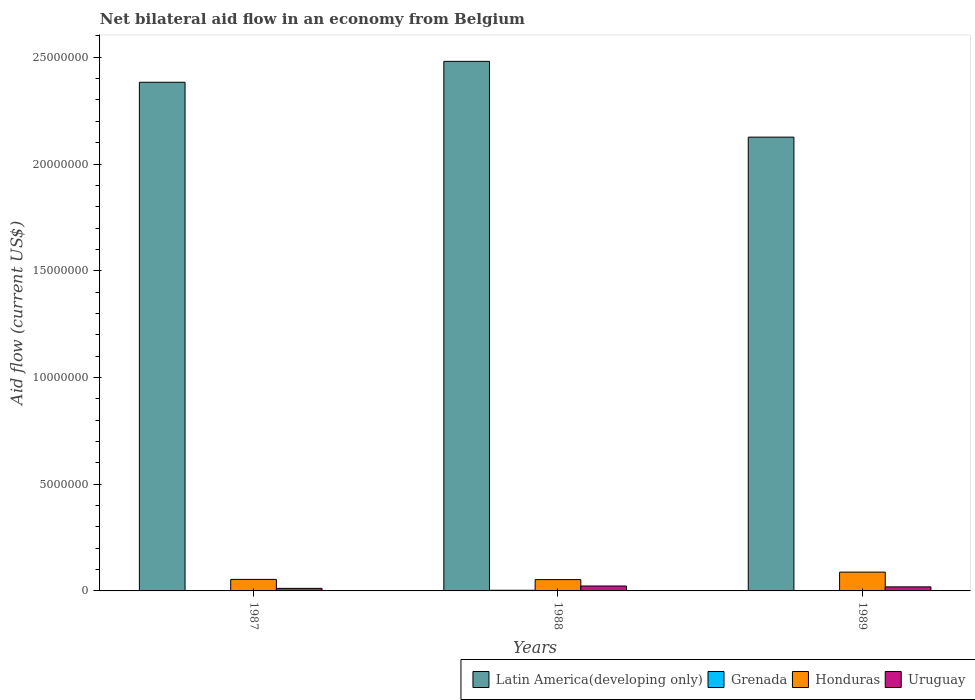How many different coloured bars are there?
Your response must be concise. 4. Are the number of bars per tick equal to the number of legend labels?
Offer a very short reply. Yes. Are the number of bars on each tick of the X-axis equal?
Offer a terse response. Yes. How many bars are there on the 1st tick from the right?
Your answer should be compact. 4. What is the net bilateral aid flow in Latin America(developing only) in 1988?
Your answer should be compact. 2.48e+07. Across all years, what is the minimum net bilateral aid flow in Latin America(developing only)?
Your response must be concise. 2.13e+07. What is the total net bilateral aid flow in Uruguay in the graph?
Provide a succinct answer. 5.40e+05. What is the difference between the net bilateral aid flow in Grenada in 1987 and that in 1989?
Keep it short and to the point. 0. What is the difference between the net bilateral aid flow in Uruguay in 1988 and the net bilateral aid flow in Honduras in 1989?
Your answer should be compact. -6.50e+05. What is the average net bilateral aid flow in Grenada per year?
Provide a succinct answer. 1.67e+04. In how many years, is the net bilateral aid flow in Honduras greater than 7000000 US$?
Your answer should be very brief. 0. What is the ratio of the net bilateral aid flow in Latin America(developing only) in 1987 to that in 1989?
Your response must be concise. 1.12. Is the net bilateral aid flow in Grenada in 1988 less than that in 1989?
Your answer should be compact. No. What is the difference between the highest and the second highest net bilateral aid flow in Grenada?
Your answer should be very brief. 2.00e+04. What is the difference between the highest and the lowest net bilateral aid flow in Honduras?
Make the answer very short. 3.50e+05. What does the 3rd bar from the left in 1988 represents?
Keep it short and to the point. Honduras. What does the 2nd bar from the right in 1987 represents?
Give a very brief answer. Honduras. Is it the case that in every year, the sum of the net bilateral aid flow in Grenada and net bilateral aid flow in Honduras is greater than the net bilateral aid flow in Latin America(developing only)?
Give a very brief answer. No. Are all the bars in the graph horizontal?
Keep it short and to the point. No. What is the difference between two consecutive major ticks on the Y-axis?
Provide a succinct answer. 5.00e+06. Are the values on the major ticks of Y-axis written in scientific E-notation?
Provide a succinct answer. No. Does the graph contain any zero values?
Make the answer very short. No. Where does the legend appear in the graph?
Give a very brief answer. Bottom right. How many legend labels are there?
Keep it short and to the point. 4. How are the legend labels stacked?
Your answer should be very brief. Horizontal. What is the title of the graph?
Provide a succinct answer. Net bilateral aid flow in an economy from Belgium. Does "Libya" appear as one of the legend labels in the graph?
Provide a short and direct response. No. What is the Aid flow (current US$) of Latin America(developing only) in 1987?
Offer a very short reply. 2.38e+07. What is the Aid flow (current US$) of Honduras in 1987?
Make the answer very short. 5.40e+05. What is the Aid flow (current US$) in Uruguay in 1987?
Your response must be concise. 1.20e+05. What is the Aid flow (current US$) in Latin America(developing only) in 1988?
Offer a very short reply. 2.48e+07. What is the Aid flow (current US$) of Grenada in 1988?
Offer a terse response. 3.00e+04. What is the Aid flow (current US$) of Honduras in 1988?
Ensure brevity in your answer.  5.30e+05. What is the Aid flow (current US$) of Uruguay in 1988?
Offer a terse response. 2.30e+05. What is the Aid flow (current US$) of Latin America(developing only) in 1989?
Offer a terse response. 2.13e+07. What is the Aid flow (current US$) of Honduras in 1989?
Provide a short and direct response. 8.80e+05. Across all years, what is the maximum Aid flow (current US$) of Latin America(developing only)?
Keep it short and to the point. 2.48e+07. Across all years, what is the maximum Aid flow (current US$) of Honduras?
Offer a terse response. 8.80e+05. Across all years, what is the maximum Aid flow (current US$) in Uruguay?
Your response must be concise. 2.30e+05. Across all years, what is the minimum Aid flow (current US$) in Latin America(developing only)?
Give a very brief answer. 2.13e+07. Across all years, what is the minimum Aid flow (current US$) in Grenada?
Provide a succinct answer. 10000. Across all years, what is the minimum Aid flow (current US$) of Honduras?
Provide a succinct answer. 5.30e+05. Across all years, what is the minimum Aid flow (current US$) of Uruguay?
Offer a very short reply. 1.20e+05. What is the total Aid flow (current US$) of Latin America(developing only) in the graph?
Provide a short and direct response. 6.99e+07. What is the total Aid flow (current US$) in Honduras in the graph?
Offer a terse response. 1.95e+06. What is the total Aid flow (current US$) in Uruguay in the graph?
Provide a succinct answer. 5.40e+05. What is the difference between the Aid flow (current US$) of Latin America(developing only) in 1987 and that in 1988?
Make the answer very short. -9.80e+05. What is the difference between the Aid flow (current US$) of Honduras in 1987 and that in 1988?
Your response must be concise. 10000. What is the difference between the Aid flow (current US$) of Uruguay in 1987 and that in 1988?
Provide a short and direct response. -1.10e+05. What is the difference between the Aid flow (current US$) in Latin America(developing only) in 1987 and that in 1989?
Provide a short and direct response. 2.57e+06. What is the difference between the Aid flow (current US$) in Grenada in 1987 and that in 1989?
Ensure brevity in your answer.  0. What is the difference between the Aid flow (current US$) of Honduras in 1987 and that in 1989?
Your answer should be very brief. -3.40e+05. What is the difference between the Aid flow (current US$) of Uruguay in 1987 and that in 1989?
Give a very brief answer. -7.00e+04. What is the difference between the Aid flow (current US$) of Latin America(developing only) in 1988 and that in 1989?
Make the answer very short. 3.55e+06. What is the difference between the Aid flow (current US$) in Grenada in 1988 and that in 1989?
Keep it short and to the point. 2.00e+04. What is the difference between the Aid flow (current US$) of Honduras in 1988 and that in 1989?
Offer a terse response. -3.50e+05. What is the difference between the Aid flow (current US$) of Uruguay in 1988 and that in 1989?
Give a very brief answer. 4.00e+04. What is the difference between the Aid flow (current US$) in Latin America(developing only) in 1987 and the Aid flow (current US$) in Grenada in 1988?
Your answer should be compact. 2.38e+07. What is the difference between the Aid flow (current US$) of Latin America(developing only) in 1987 and the Aid flow (current US$) of Honduras in 1988?
Offer a terse response. 2.33e+07. What is the difference between the Aid flow (current US$) of Latin America(developing only) in 1987 and the Aid flow (current US$) of Uruguay in 1988?
Your answer should be very brief. 2.36e+07. What is the difference between the Aid flow (current US$) of Grenada in 1987 and the Aid flow (current US$) of Honduras in 1988?
Ensure brevity in your answer.  -5.20e+05. What is the difference between the Aid flow (current US$) in Grenada in 1987 and the Aid flow (current US$) in Uruguay in 1988?
Keep it short and to the point. -2.20e+05. What is the difference between the Aid flow (current US$) of Latin America(developing only) in 1987 and the Aid flow (current US$) of Grenada in 1989?
Offer a very short reply. 2.38e+07. What is the difference between the Aid flow (current US$) of Latin America(developing only) in 1987 and the Aid flow (current US$) of Honduras in 1989?
Ensure brevity in your answer.  2.30e+07. What is the difference between the Aid flow (current US$) in Latin America(developing only) in 1987 and the Aid flow (current US$) in Uruguay in 1989?
Provide a succinct answer. 2.36e+07. What is the difference between the Aid flow (current US$) in Grenada in 1987 and the Aid flow (current US$) in Honduras in 1989?
Offer a very short reply. -8.70e+05. What is the difference between the Aid flow (current US$) in Honduras in 1987 and the Aid flow (current US$) in Uruguay in 1989?
Your response must be concise. 3.50e+05. What is the difference between the Aid flow (current US$) of Latin America(developing only) in 1988 and the Aid flow (current US$) of Grenada in 1989?
Provide a short and direct response. 2.48e+07. What is the difference between the Aid flow (current US$) of Latin America(developing only) in 1988 and the Aid flow (current US$) of Honduras in 1989?
Your response must be concise. 2.39e+07. What is the difference between the Aid flow (current US$) in Latin America(developing only) in 1988 and the Aid flow (current US$) in Uruguay in 1989?
Your answer should be compact. 2.46e+07. What is the difference between the Aid flow (current US$) in Grenada in 1988 and the Aid flow (current US$) in Honduras in 1989?
Offer a very short reply. -8.50e+05. What is the average Aid flow (current US$) in Latin America(developing only) per year?
Offer a very short reply. 2.33e+07. What is the average Aid flow (current US$) in Grenada per year?
Make the answer very short. 1.67e+04. What is the average Aid flow (current US$) of Honduras per year?
Keep it short and to the point. 6.50e+05. What is the average Aid flow (current US$) in Uruguay per year?
Give a very brief answer. 1.80e+05. In the year 1987, what is the difference between the Aid flow (current US$) in Latin America(developing only) and Aid flow (current US$) in Grenada?
Offer a terse response. 2.38e+07. In the year 1987, what is the difference between the Aid flow (current US$) of Latin America(developing only) and Aid flow (current US$) of Honduras?
Your answer should be very brief. 2.33e+07. In the year 1987, what is the difference between the Aid flow (current US$) of Latin America(developing only) and Aid flow (current US$) of Uruguay?
Give a very brief answer. 2.37e+07. In the year 1987, what is the difference between the Aid flow (current US$) of Grenada and Aid flow (current US$) of Honduras?
Offer a terse response. -5.30e+05. In the year 1988, what is the difference between the Aid flow (current US$) in Latin America(developing only) and Aid flow (current US$) in Grenada?
Keep it short and to the point. 2.48e+07. In the year 1988, what is the difference between the Aid flow (current US$) in Latin America(developing only) and Aid flow (current US$) in Honduras?
Your answer should be very brief. 2.43e+07. In the year 1988, what is the difference between the Aid flow (current US$) in Latin America(developing only) and Aid flow (current US$) in Uruguay?
Give a very brief answer. 2.46e+07. In the year 1988, what is the difference between the Aid flow (current US$) in Grenada and Aid flow (current US$) in Honduras?
Keep it short and to the point. -5.00e+05. In the year 1988, what is the difference between the Aid flow (current US$) in Grenada and Aid flow (current US$) in Uruguay?
Offer a terse response. -2.00e+05. In the year 1988, what is the difference between the Aid flow (current US$) in Honduras and Aid flow (current US$) in Uruguay?
Offer a terse response. 3.00e+05. In the year 1989, what is the difference between the Aid flow (current US$) of Latin America(developing only) and Aid flow (current US$) of Grenada?
Your answer should be compact. 2.12e+07. In the year 1989, what is the difference between the Aid flow (current US$) of Latin America(developing only) and Aid flow (current US$) of Honduras?
Provide a short and direct response. 2.04e+07. In the year 1989, what is the difference between the Aid flow (current US$) in Latin America(developing only) and Aid flow (current US$) in Uruguay?
Your answer should be compact. 2.11e+07. In the year 1989, what is the difference between the Aid flow (current US$) of Grenada and Aid flow (current US$) of Honduras?
Provide a short and direct response. -8.70e+05. In the year 1989, what is the difference between the Aid flow (current US$) of Honduras and Aid flow (current US$) of Uruguay?
Your answer should be very brief. 6.90e+05. What is the ratio of the Aid flow (current US$) in Latin America(developing only) in 1987 to that in 1988?
Your answer should be compact. 0.96. What is the ratio of the Aid flow (current US$) of Grenada in 1987 to that in 1988?
Give a very brief answer. 0.33. What is the ratio of the Aid flow (current US$) in Honduras in 1987 to that in 1988?
Keep it short and to the point. 1.02. What is the ratio of the Aid flow (current US$) of Uruguay in 1987 to that in 1988?
Your answer should be very brief. 0.52. What is the ratio of the Aid flow (current US$) of Latin America(developing only) in 1987 to that in 1989?
Your answer should be compact. 1.12. What is the ratio of the Aid flow (current US$) of Grenada in 1987 to that in 1989?
Keep it short and to the point. 1. What is the ratio of the Aid flow (current US$) of Honduras in 1987 to that in 1989?
Give a very brief answer. 0.61. What is the ratio of the Aid flow (current US$) of Uruguay in 1987 to that in 1989?
Ensure brevity in your answer.  0.63. What is the ratio of the Aid flow (current US$) of Latin America(developing only) in 1988 to that in 1989?
Offer a terse response. 1.17. What is the ratio of the Aid flow (current US$) of Honduras in 1988 to that in 1989?
Your answer should be compact. 0.6. What is the ratio of the Aid flow (current US$) of Uruguay in 1988 to that in 1989?
Ensure brevity in your answer.  1.21. What is the difference between the highest and the second highest Aid flow (current US$) in Latin America(developing only)?
Your answer should be compact. 9.80e+05. What is the difference between the highest and the lowest Aid flow (current US$) of Latin America(developing only)?
Keep it short and to the point. 3.55e+06. What is the difference between the highest and the lowest Aid flow (current US$) in Grenada?
Offer a terse response. 2.00e+04. What is the difference between the highest and the lowest Aid flow (current US$) of Honduras?
Your answer should be compact. 3.50e+05. 